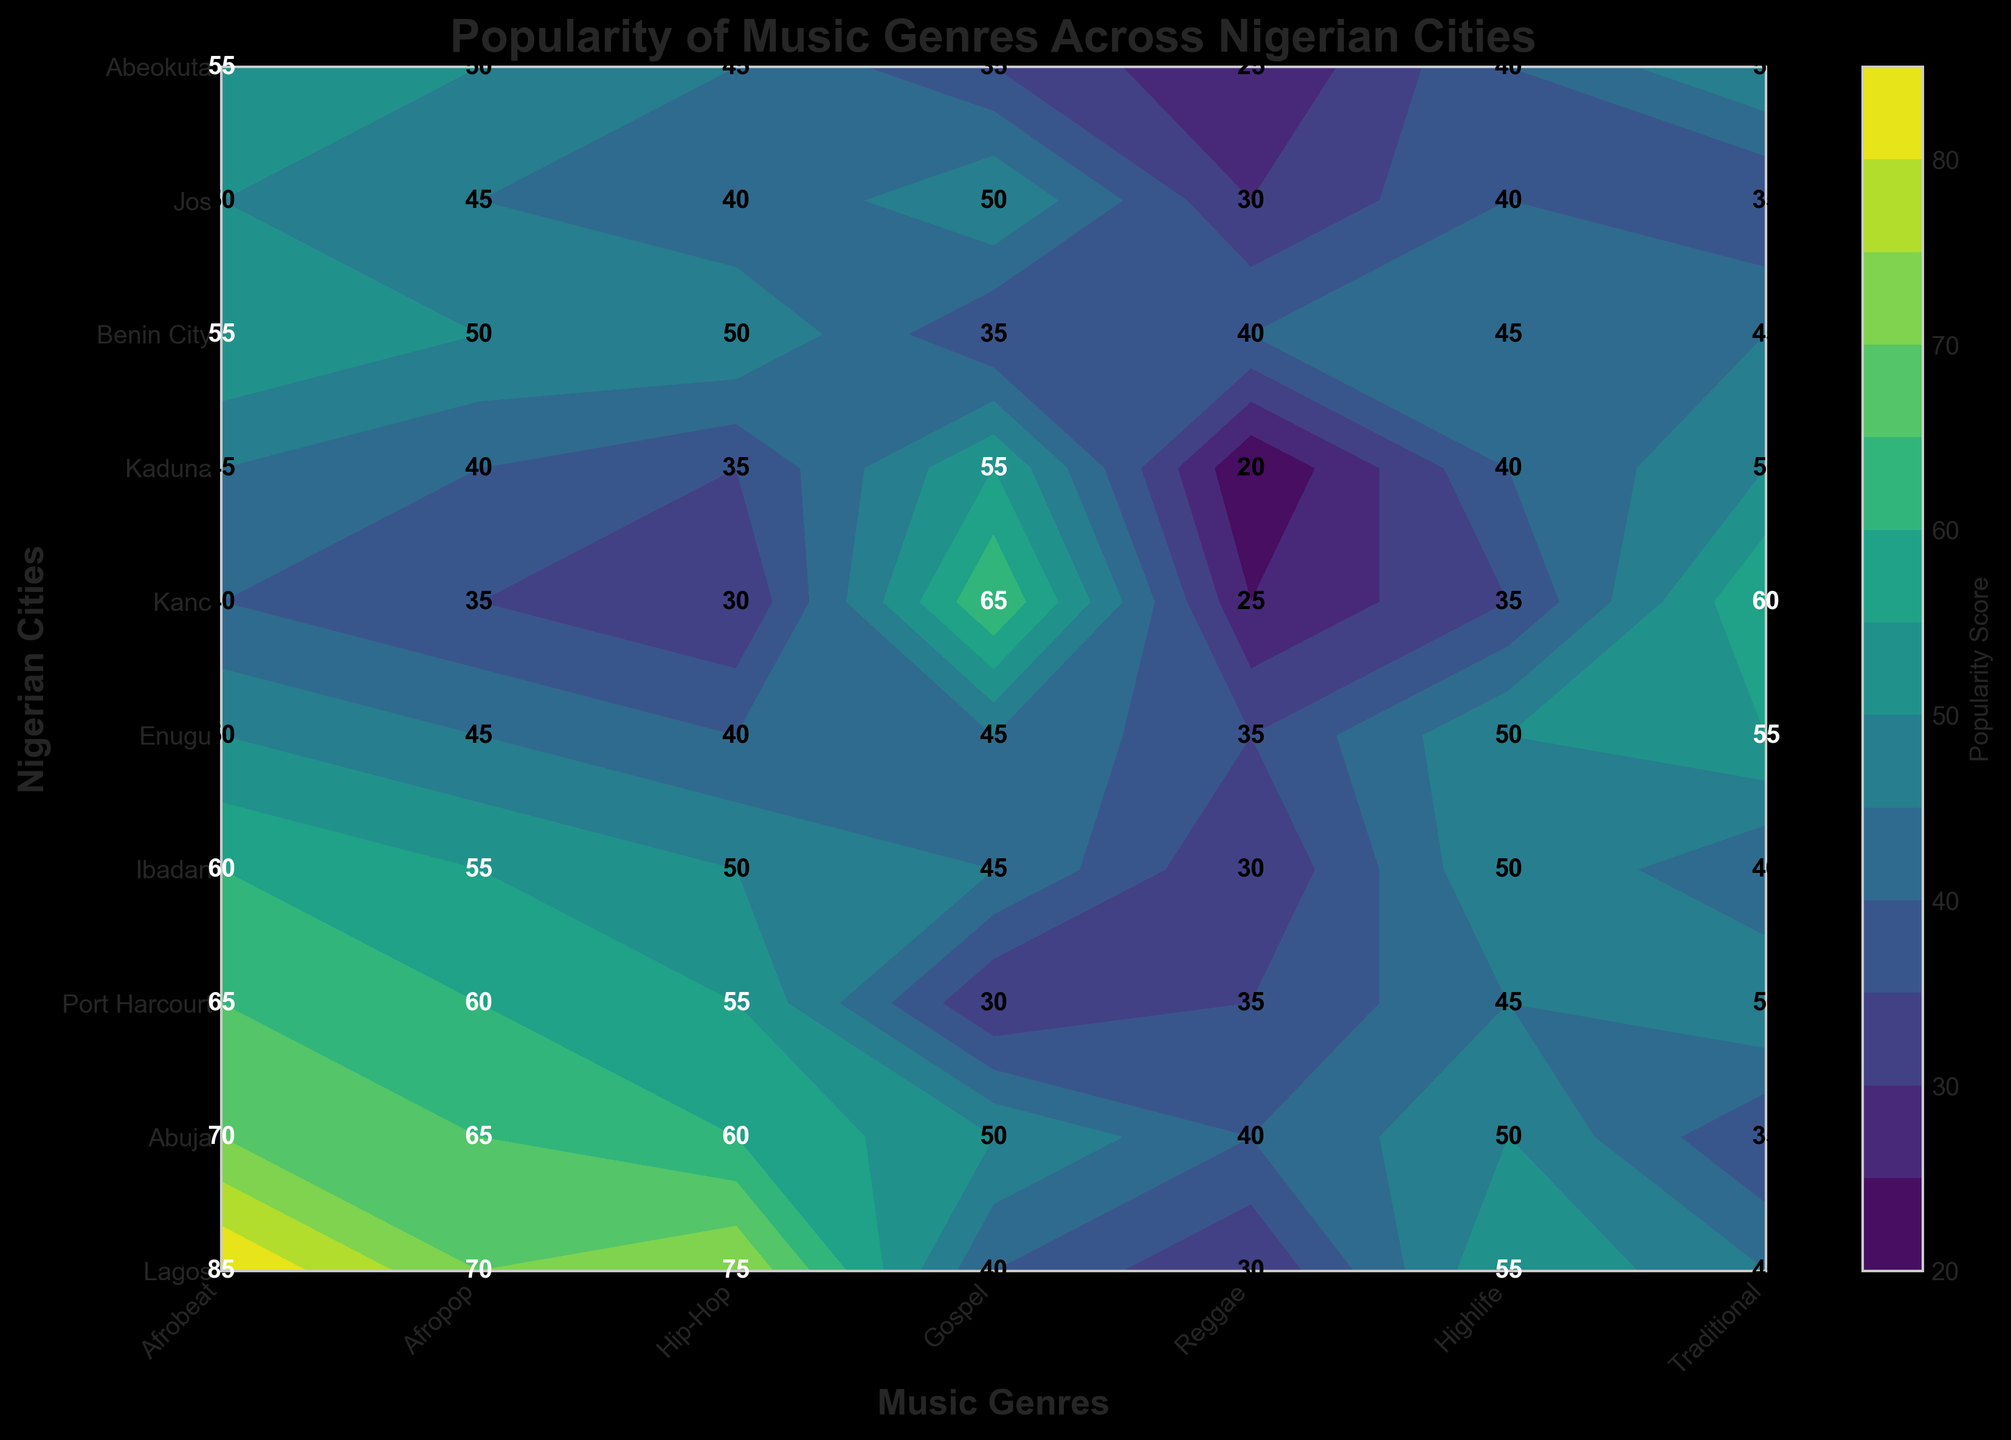What is the title of the plot? The title is typically located at the top of the plot and is set to give an overview of the data presented. By looking at the top center of the plot, you can see the title as "Popularity of Music Genres Across Nigerian Cities".
Answer: Popularity of Music Genres Across Nigerian Cities Which city has the highest popularity for Afrobeat? To find this, look at the color intensity of the contour and the numerical label for Afrobeat across all cities. The city with the highest value here is Lagos, with a popularity score of 85.
Answer: Lagos How does the popularity of Gospel music compare between Abuja and Kaduna? Look at the numerical labels and color intensity for Gospel in both Abuja and Kaduna. Abuja has a Gospel popularity of 50, while Kaduna has 55. So, Gospel is slightly more popular in Kaduna.
Answer: Kaduna What is the average popularity score of Highlife across all cities? First, find the popularity scores for Highlife in all cities: 55, 50, 45, 50, 50, 35, 40, 45, 40, 40. Sum up these values (55+50+45+50+50+35+40+45+40+40 = 450) and then divide by the number of cities (10). Thus, the average is 450/10 = 45.
Answer: 45 Which genre is more popular in Kano, Gospel or Traditional music? Compare the numerical labels for Gospel and Traditional music in the city of Kano. Gospel has a score of 65, whereas Traditional has a score of 60.
Answer: Gospel In which city is Highlife equally popular compared to Jos? Look at the popularity score for Highlife in Jos, which is 40. Find the other cities with the same score: These cities are Kaduna and Abeokuta, each with a score of 40 for Highlife.
Answer: Kaduna and Abeokuta By how much does the popularity of Hip-Hop in Lagos exceed that in Kano? Find the numerical labels for Hip-Hop in Lagos (75) and in Kano (30). Subtract the smaller value from the larger: 75 - 30 = 45.
Answer: 45 What is the least popular music genre in Benin City? Identify the genre with the lowest numerical label value for Benin City. By inspection, Reggae has the lowest popularity score of 40.
Answer: Reggae Which city has the closest popularity score for Traditional music to Abuja's score for Gospel music? The Gospel score for Abuja is 50. Look for cities with Traditional music scores close to this value. Kaduna has a Traditional score of 50, exactly matching Abuja's Gospel score.
Answer: Kaduna 